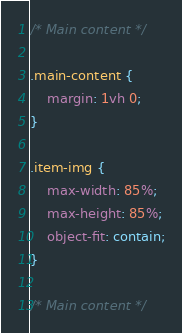Convert code to text. <code><loc_0><loc_0><loc_500><loc_500><_CSS_>/* Main content */

.main-content {
	margin: 1vh 0;
}

.item-img {
	max-width: 85%;
	max-height: 85%;
	object-fit: contain;
}

/* Main content */</code> 